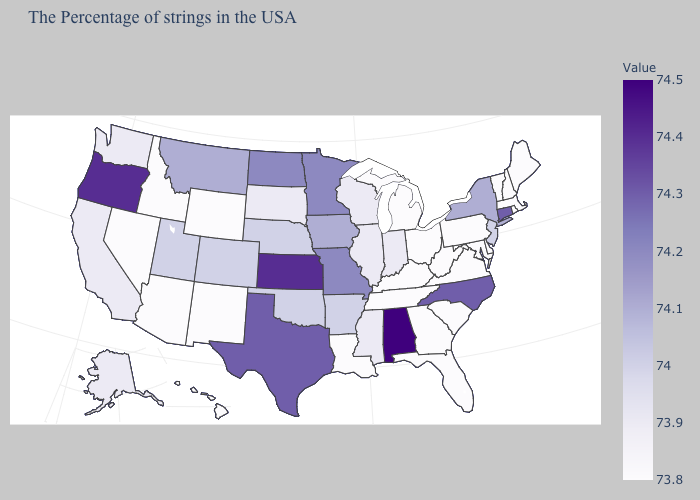Which states hav the highest value in the MidWest?
Keep it brief. Kansas. Does the map have missing data?
Quick response, please. No. Does Oregon have a lower value than Idaho?
Write a very short answer. No. Among the states that border Arizona , does Nevada have the highest value?
Be succinct. No. Which states have the highest value in the USA?
Answer briefly. Alabama. 